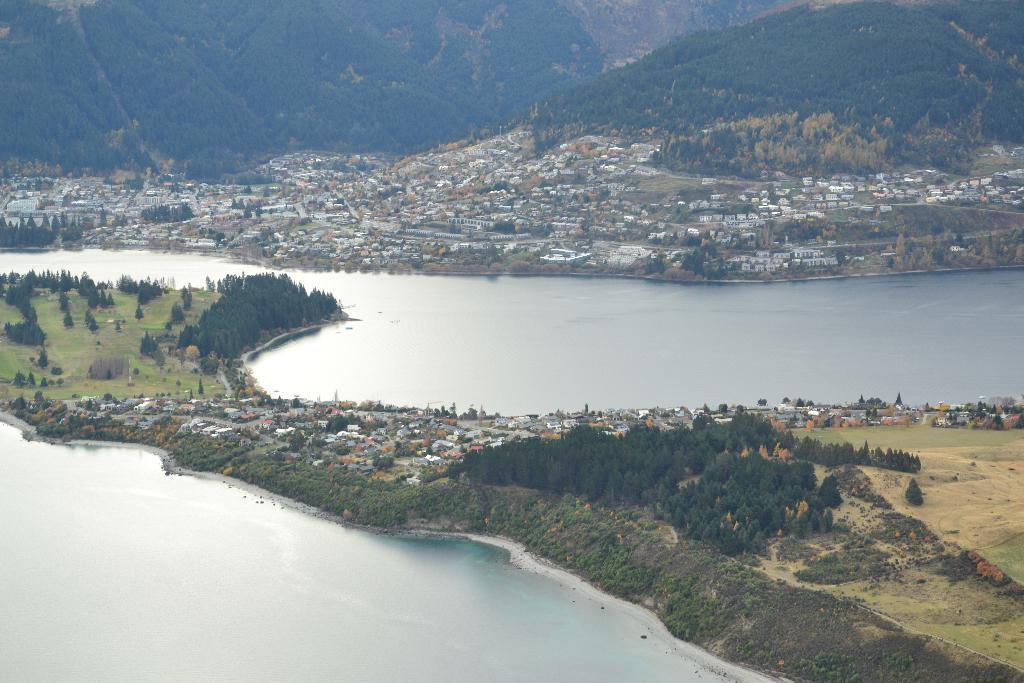What is the primary element visible in the image? There is water in the image. What type of natural vegetation can be seen in the image? There are trees in the image. Are there any man-made structures visible in the image? Yes, there are buildings in the image. What can be seen in the distance in the image? There are mountains visible in the background of the image. How many straws are floating on the water in the image? There are no straws visible in the image; it only features water, trees, buildings, and mountains. 